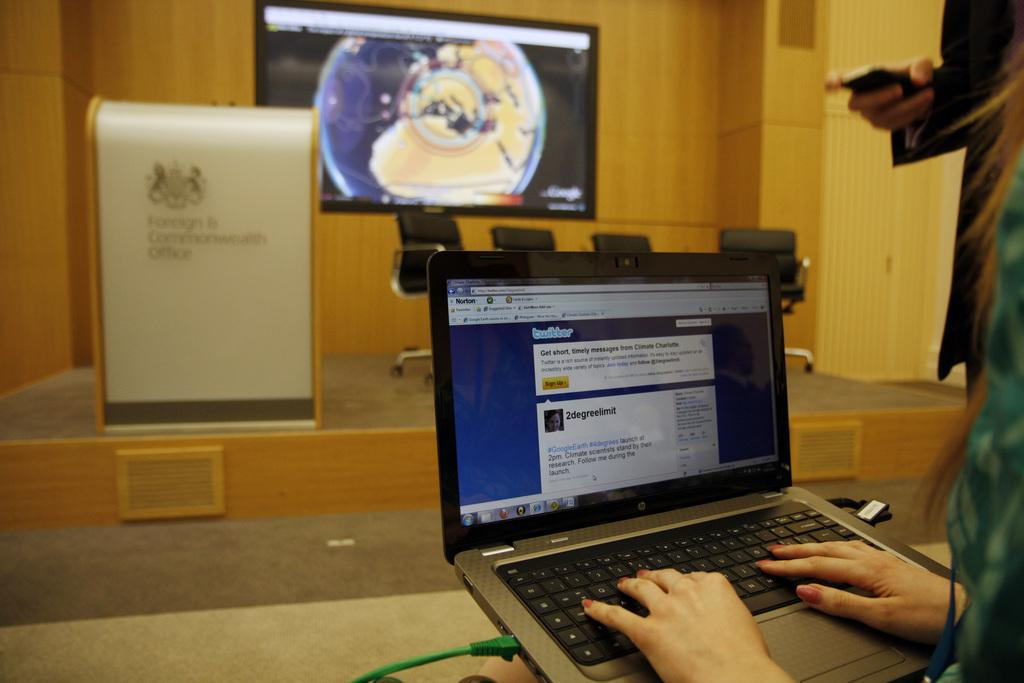<image>
Relay a brief, clear account of the picture shown. A person in a lecture hall on their computer looking at twitter. 